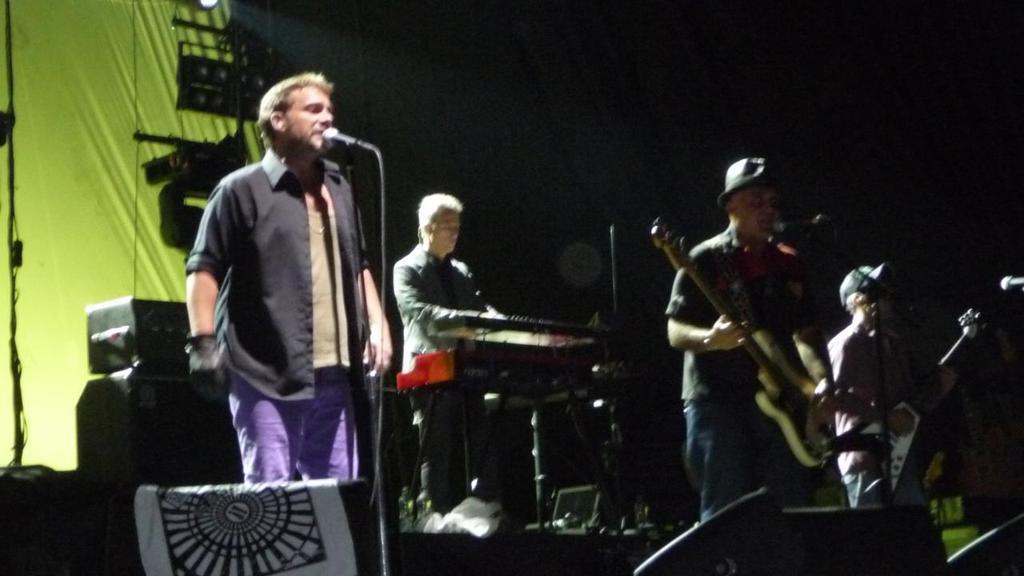Describe this image in one or two sentences. In this picture we can see four men on stage and they are playing musical instruments such as guitar, piano and on left side person singing on mic and in the background we can see cloth and it is dark. 